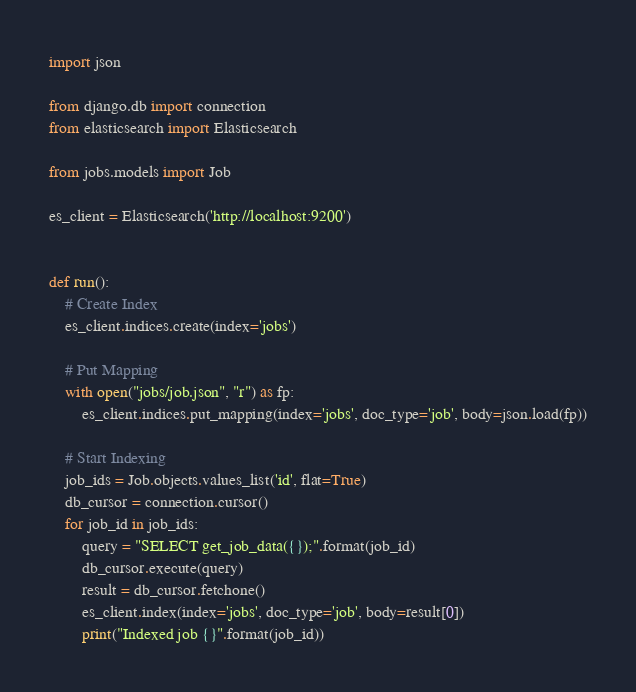<code> <loc_0><loc_0><loc_500><loc_500><_Python_>import json

from django.db import connection
from elasticsearch import Elasticsearch

from jobs.models import Job

es_client = Elasticsearch('http://localhost:9200')


def run():
    # Create Index
    es_client.indices.create(index='jobs')

    # Put Mapping
    with open("jobs/job.json", "r") as fp:
        es_client.indices.put_mapping(index='jobs', doc_type='job', body=json.load(fp))

    # Start Indexing
    job_ids = Job.objects.values_list('id', flat=True)
    db_cursor = connection.cursor()
    for job_id in job_ids:
        query = "SELECT get_job_data({});".format(job_id)
        db_cursor.execute(query)
        result = db_cursor.fetchone()
        es_client.index(index='jobs', doc_type='job', body=result[0])
        print("Indexed job {}".format(job_id))
</code> 